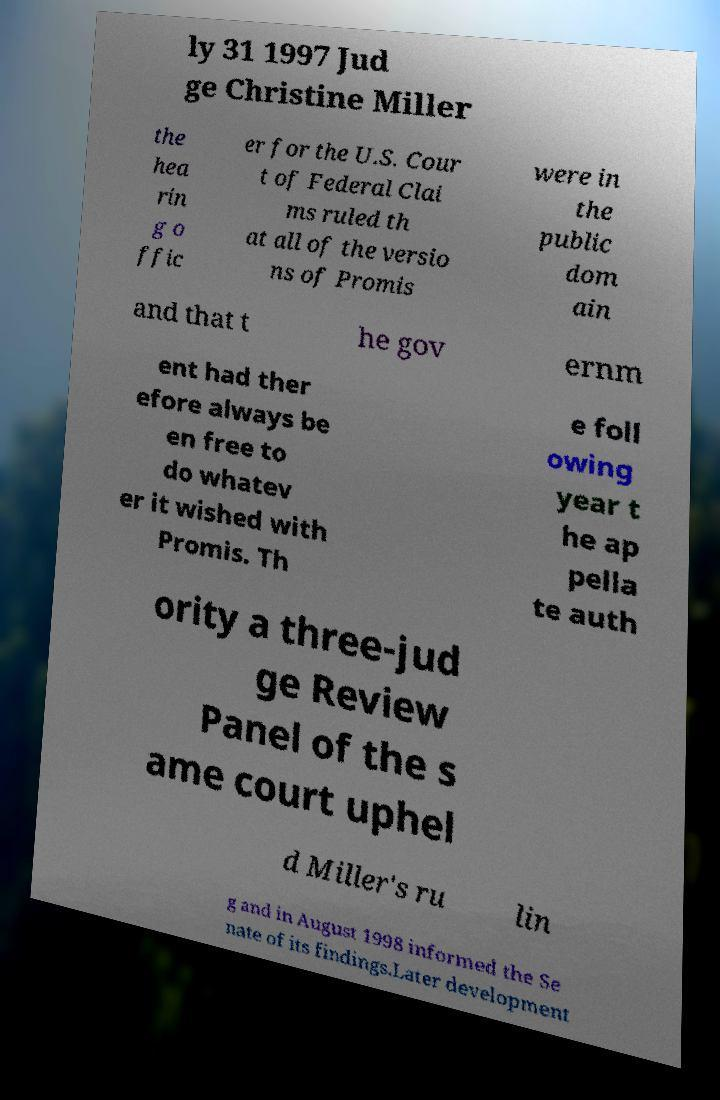Can you accurately transcribe the text from the provided image for me? ly 31 1997 Jud ge Christine Miller the hea rin g o ffic er for the U.S. Cour t of Federal Clai ms ruled th at all of the versio ns of Promis were in the public dom ain and that t he gov ernm ent had ther efore always be en free to do whatev er it wished with Promis. Th e foll owing year t he ap pella te auth ority a three-jud ge Review Panel of the s ame court uphel d Miller's ru lin g and in August 1998 informed the Se nate of its findings.Later development 